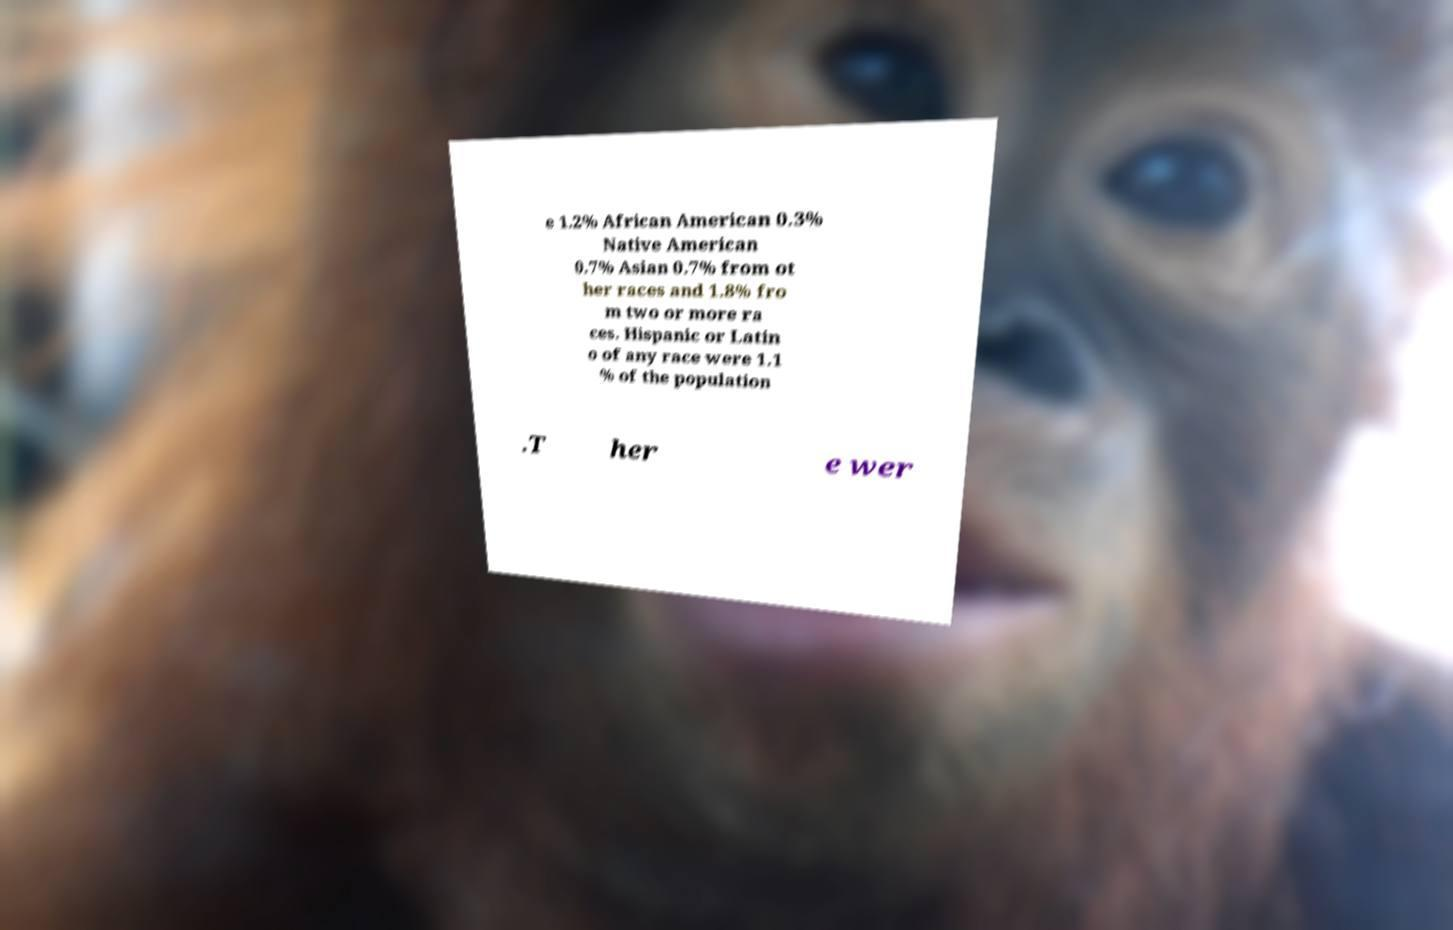I need the written content from this picture converted into text. Can you do that? e 1.2% African American 0.3% Native American 0.7% Asian 0.7% from ot her races and 1.8% fro m two or more ra ces. Hispanic or Latin o of any race were 1.1 % of the population .T her e wer 